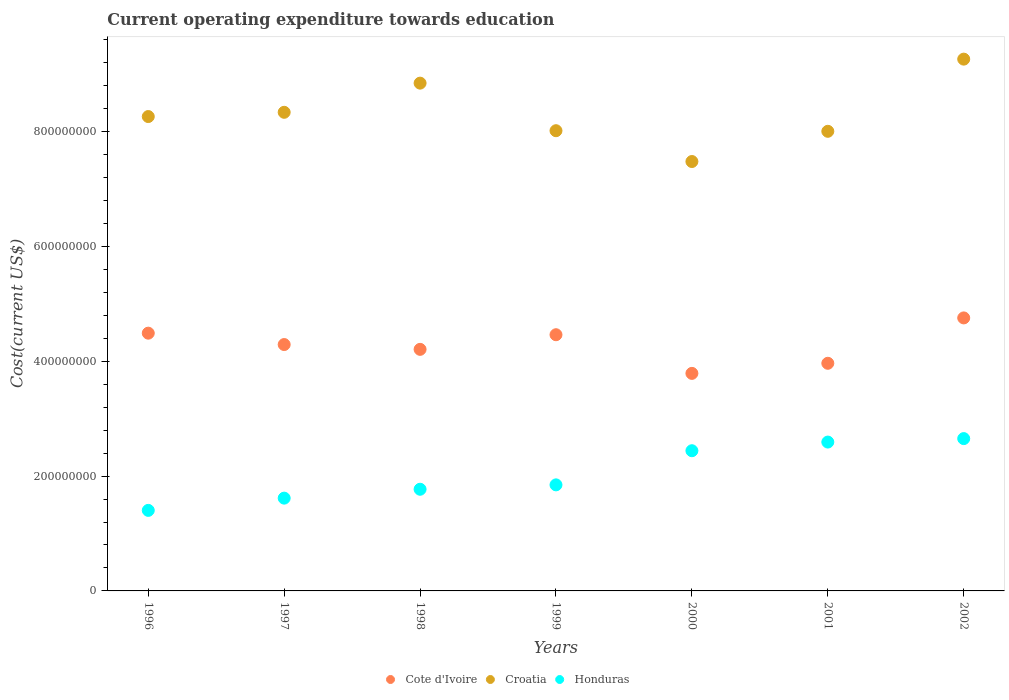Is the number of dotlines equal to the number of legend labels?
Give a very brief answer. Yes. What is the expenditure towards education in Honduras in 1997?
Ensure brevity in your answer.  1.62e+08. Across all years, what is the maximum expenditure towards education in Cote d'Ivoire?
Provide a short and direct response. 4.75e+08. Across all years, what is the minimum expenditure towards education in Cote d'Ivoire?
Ensure brevity in your answer.  3.79e+08. In which year was the expenditure towards education in Cote d'Ivoire minimum?
Provide a succinct answer. 2000. What is the total expenditure towards education in Croatia in the graph?
Your response must be concise. 5.82e+09. What is the difference between the expenditure towards education in Croatia in 1999 and that in 2002?
Offer a very short reply. -1.25e+08. What is the difference between the expenditure towards education in Honduras in 1997 and the expenditure towards education in Cote d'Ivoire in 2000?
Offer a very short reply. -2.17e+08. What is the average expenditure towards education in Croatia per year?
Make the answer very short. 8.31e+08. In the year 1998, what is the difference between the expenditure towards education in Honduras and expenditure towards education in Cote d'Ivoire?
Provide a succinct answer. -2.44e+08. In how many years, is the expenditure towards education in Honduras greater than 760000000 US$?
Ensure brevity in your answer.  0. What is the ratio of the expenditure towards education in Croatia in 1998 to that in 1999?
Keep it short and to the point. 1.1. What is the difference between the highest and the second highest expenditure towards education in Honduras?
Your answer should be very brief. 6.03e+06. What is the difference between the highest and the lowest expenditure towards education in Cote d'Ivoire?
Ensure brevity in your answer.  9.66e+07. In how many years, is the expenditure towards education in Cote d'Ivoire greater than the average expenditure towards education in Cote d'Ivoire taken over all years?
Make the answer very short. 4. Does the expenditure towards education in Cote d'Ivoire monotonically increase over the years?
Give a very brief answer. No. Is the expenditure towards education in Croatia strictly greater than the expenditure towards education in Cote d'Ivoire over the years?
Make the answer very short. Yes. Is the expenditure towards education in Honduras strictly less than the expenditure towards education in Croatia over the years?
Offer a very short reply. Yes. How many years are there in the graph?
Your answer should be very brief. 7. Does the graph contain grids?
Your response must be concise. No. How are the legend labels stacked?
Make the answer very short. Horizontal. What is the title of the graph?
Keep it short and to the point. Current operating expenditure towards education. What is the label or title of the Y-axis?
Provide a short and direct response. Cost(current US$). What is the Cost(current US$) of Cote d'Ivoire in 1996?
Offer a very short reply. 4.49e+08. What is the Cost(current US$) in Croatia in 1996?
Your answer should be compact. 8.26e+08. What is the Cost(current US$) in Honduras in 1996?
Provide a short and direct response. 1.40e+08. What is the Cost(current US$) in Cote d'Ivoire in 1997?
Your response must be concise. 4.29e+08. What is the Cost(current US$) of Croatia in 1997?
Provide a short and direct response. 8.34e+08. What is the Cost(current US$) of Honduras in 1997?
Your response must be concise. 1.62e+08. What is the Cost(current US$) of Cote d'Ivoire in 1998?
Your answer should be compact. 4.21e+08. What is the Cost(current US$) in Croatia in 1998?
Your answer should be very brief. 8.84e+08. What is the Cost(current US$) of Honduras in 1998?
Provide a succinct answer. 1.77e+08. What is the Cost(current US$) of Cote d'Ivoire in 1999?
Your response must be concise. 4.46e+08. What is the Cost(current US$) of Croatia in 1999?
Your answer should be compact. 8.02e+08. What is the Cost(current US$) of Honduras in 1999?
Your answer should be compact. 1.85e+08. What is the Cost(current US$) of Cote d'Ivoire in 2000?
Keep it short and to the point. 3.79e+08. What is the Cost(current US$) in Croatia in 2000?
Provide a short and direct response. 7.48e+08. What is the Cost(current US$) in Honduras in 2000?
Provide a succinct answer. 2.44e+08. What is the Cost(current US$) of Cote d'Ivoire in 2001?
Provide a succinct answer. 3.96e+08. What is the Cost(current US$) of Croatia in 2001?
Offer a terse response. 8.00e+08. What is the Cost(current US$) of Honduras in 2001?
Ensure brevity in your answer.  2.59e+08. What is the Cost(current US$) of Cote d'Ivoire in 2002?
Your response must be concise. 4.75e+08. What is the Cost(current US$) of Croatia in 2002?
Ensure brevity in your answer.  9.26e+08. What is the Cost(current US$) of Honduras in 2002?
Give a very brief answer. 2.65e+08. Across all years, what is the maximum Cost(current US$) in Cote d'Ivoire?
Offer a very short reply. 4.75e+08. Across all years, what is the maximum Cost(current US$) in Croatia?
Provide a succinct answer. 9.26e+08. Across all years, what is the maximum Cost(current US$) in Honduras?
Ensure brevity in your answer.  2.65e+08. Across all years, what is the minimum Cost(current US$) of Cote d'Ivoire?
Your answer should be compact. 3.79e+08. Across all years, what is the minimum Cost(current US$) of Croatia?
Ensure brevity in your answer.  7.48e+08. Across all years, what is the minimum Cost(current US$) in Honduras?
Your answer should be compact. 1.40e+08. What is the total Cost(current US$) in Cote d'Ivoire in the graph?
Offer a terse response. 3.00e+09. What is the total Cost(current US$) in Croatia in the graph?
Your answer should be compact. 5.82e+09. What is the total Cost(current US$) in Honduras in the graph?
Your answer should be very brief. 1.43e+09. What is the difference between the Cost(current US$) in Cote d'Ivoire in 1996 and that in 1997?
Your answer should be compact. 1.98e+07. What is the difference between the Cost(current US$) of Croatia in 1996 and that in 1997?
Your answer should be compact. -7.41e+06. What is the difference between the Cost(current US$) in Honduras in 1996 and that in 1997?
Your response must be concise. -2.13e+07. What is the difference between the Cost(current US$) in Cote d'Ivoire in 1996 and that in 1998?
Provide a short and direct response. 2.82e+07. What is the difference between the Cost(current US$) in Croatia in 1996 and that in 1998?
Ensure brevity in your answer.  -5.82e+07. What is the difference between the Cost(current US$) of Honduras in 1996 and that in 1998?
Offer a very short reply. -3.68e+07. What is the difference between the Cost(current US$) in Cote d'Ivoire in 1996 and that in 1999?
Your answer should be very brief. 2.71e+06. What is the difference between the Cost(current US$) of Croatia in 1996 and that in 1999?
Keep it short and to the point. 2.46e+07. What is the difference between the Cost(current US$) of Honduras in 1996 and that in 1999?
Make the answer very short. -4.44e+07. What is the difference between the Cost(current US$) in Cote d'Ivoire in 1996 and that in 2000?
Your answer should be very brief. 7.00e+07. What is the difference between the Cost(current US$) of Croatia in 1996 and that in 2000?
Provide a succinct answer. 7.83e+07. What is the difference between the Cost(current US$) in Honduras in 1996 and that in 2000?
Provide a succinct answer. -1.04e+08. What is the difference between the Cost(current US$) in Cote d'Ivoire in 1996 and that in 2001?
Make the answer very short. 5.25e+07. What is the difference between the Cost(current US$) of Croatia in 1996 and that in 2001?
Give a very brief answer. 2.57e+07. What is the difference between the Cost(current US$) of Honduras in 1996 and that in 2001?
Offer a terse response. -1.19e+08. What is the difference between the Cost(current US$) in Cote d'Ivoire in 1996 and that in 2002?
Make the answer very short. -2.66e+07. What is the difference between the Cost(current US$) of Croatia in 1996 and that in 2002?
Your answer should be compact. -1.00e+08. What is the difference between the Cost(current US$) of Honduras in 1996 and that in 2002?
Offer a very short reply. -1.25e+08. What is the difference between the Cost(current US$) in Cote d'Ivoire in 1997 and that in 1998?
Keep it short and to the point. 8.38e+06. What is the difference between the Cost(current US$) in Croatia in 1997 and that in 1998?
Your answer should be compact. -5.08e+07. What is the difference between the Cost(current US$) of Honduras in 1997 and that in 1998?
Offer a terse response. -1.55e+07. What is the difference between the Cost(current US$) in Cote d'Ivoire in 1997 and that in 1999?
Give a very brief answer. -1.71e+07. What is the difference between the Cost(current US$) of Croatia in 1997 and that in 1999?
Offer a terse response. 3.21e+07. What is the difference between the Cost(current US$) of Honduras in 1997 and that in 1999?
Make the answer very short. -2.31e+07. What is the difference between the Cost(current US$) in Cote d'Ivoire in 1997 and that in 2000?
Your answer should be very brief. 5.02e+07. What is the difference between the Cost(current US$) of Croatia in 1997 and that in 2000?
Give a very brief answer. 8.57e+07. What is the difference between the Cost(current US$) in Honduras in 1997 and that in 2000?
Give a very brief answer. -8.26e+07. What is the difference between the Cost(current US$) of Cote d'Ivoire in 1997 and that in 2001?
Provide a succinct answer. 3.26e+07. What is the difference between the Cost(current US$) of Croatia in 1997 and that in 2001?
Ensure brevity in your answer.  3.31e+07. What is the difference between the Cost(current US$) of Honduras in 1997 and that in 2001?
Offer a terse response. -9.77e+07. What is the difference between the Cost(current US$) in Cote d'Ivoire in 1997 and that in 2002?
Offer a terse response. -4.64e+07. What is the difference between the Cost(current US$) of Croatia in 1997 and that in 2002?
Ensure brevity in your answer.  -9.26e+07. What is the difference between the Cost(current US$) of Honduras in 1997 and that in 2002?
Keep it short and to the point. -1.04e+08. What is the difference between the Cost(current US$) of Cote d'Ivoire in 1998 and that in 1999?
Your answer should be compact. -2.55e+07. What is the difference between the Cost(current US$) of Croatia in 1998 and that in 1999?
Give a very brief answer. 8.28e+07. What is the difference between the Cost(current US$) in Honduras in 1998 and that in 1999?
Provide a succinct answer. -7.66e+06. What is the difference between the Cost(current US$) in Cote d'Ivoire in 1998 and that in 2000?
Provide a succinct answer. 4.18e+07. What is the difference between the Cost(current US$) of Croatia in 1998 and that in 2000?
Ensure brevity in your answer.  1.37e+08. What is the difference between the Cost(current US$) in Honduras in 1998 and that in 2000?
Keep it short and to the point. -6.71e+07. What is the difference between the Cost(current US$) in Cote d'Ivoire in 1998 and that in 2001?
Offer a terse response. 2.43e+07. What is the difference between the Cost(current US$) in Croatia in 1998 and that in 2001?
Make the answer very short. 8.39e+07. What is the difference between the Cost(current US$) in Honduras in 1998 and that in 2001?
Provide a short and direct response. -8.22e+07. What is the difference between the Cost(current US$) of Cote d'Ivoire in 1998 and that in 2002?
Your response must be concise. -5.48e+07. What is the difference between the Cost(current US$) of Croatia in 1998 and that in 2002?
Your answer should be compact. -4.18e+07. What is the difference between the Cost(current US$) of Honduras in 1998 and that in 2002?
Ensure brevity in your answer.  -8.82e+07. What is the difference between the Cost(current US$) of Cote d'Ivoire in 1999 and that in 2000?
Your answer should be very brief. 6.73e+07. What is the difference between the Cost(current US$) in Croatia in 1999 and that in 2000?
Your answer should be compact. 5.37e+07. What is the difference between the Cost(current US$) of Honduras in 1999 and that in 2000?
Make the answer very short. -5.94e+07. What is the difference between the Cost(current US$) in Cote d'Ivoire in 1999 and that in 2001?
Make the answer very short. 4.97e+07. What is the difference between the Cost(current US$) of Croatia in 1999 and that in 2001?
Provide a succinct answer. 1.05e+06. What is the difference between the Cost(current US$) of Honduras in 1999 and that in 2001?
Your answer should be very brief. -7.45e+07. What is the difference between the Cost(current US$) of Cote d'Ivoire in 1999 and that in 2002?
Make the answer very short. -2.93e+07. What is the difference between the Cost(current US$) in Croatia in 1999 and that in 2002?
Your answer should be very brief. -1.25e+08. What is the difference between the Cost(current US$) in Honduras in 1999 and that in 2002?
Offer a very short reply. -8.06e+07. What is the difference between the Cost(current US$) in Cote d'Ivoire in 2000 and that in 2001?
Provide a short and direct response. -1.76e+07. What is the difference between the Cost(current US$) of Croatia in 2000 and that in 2001?
Keep it short and to the point. -5.26e+07. What is the difference between the Cost(current US$) in Honduras in 2000 and that in 2001?
Provide a succinct answer. -1.51e+07. What is the difference between the Cost(current US$) in Cote d'Ivoire in 2000 and that in 2002?
Provide a succinct answer. -9.66e+07. What is the difference between the Cost(current US$) in Croatia in 2000 and that in 2002?
Provide a succinct answer. -1.78e+08. What is the difference between the Cost(current US$) of Honduras in 2000 and that in 2002?
Provide a short and direct response. -2.11e+07. What is the difference between the Cost(current US$) of Cote d'Ivoire in 2001 and that in 2002?
Provide a short and direct response. -7.90e+07. What is the difference between the Cost(current US$) in Croatia in 2001 and that in 2002?
Provide a short and direct response. -1.26e+08. What is the difference between the Cost(current US$) of Honduras in 2001 and that in 2002?
Your answer should be compact. -6.03e+06. What is the difference between the Cost(current US$) in Cote d'Ivoire in 1996 and the Cost(current US$) in Croatia in 1997?
Your answer should be compact. -3.85e+08. What is the difference between the Cost(current US$) in Cote d'Ivoire in 1996 and the Cost(current US$) in Honduras in 1997?
Your answer should be very brief. 2.87e+08. What is the difference between the Cost(current US$) of Croatia in 1996 and the Cost(current US$) of Honduras in 1997?
Offer a very short reply. 6.65e+08. What is the difference between the Cost(current US$) in Cote d'Ivoire in 1996 and the Cost(current US$) in Croatia in 1998?
Offer a terse response. -4.35e+08. What is the difference between the Cost(current US$) of Cote d'Ivoire in 1996 and the Cost(current US$) of Honduras in 1998?
Ensure brevity in your answer.  2.72e+08. What is the difference between the Cost(current US$) of Croatia in 1996 and the Cost(current US$) of Honduras in 1998?
Ensure brevity in your answer.  6.49e+08. What is the difference between the Cost(current US$) of Cote d'Ivoire in 1996 and the Cost(current US$) of Croatia in 1999?
Give a very brief answer. -3.53e+08. What is the difference between the Cost(current US$) in Cote d'Ivoire in 1996 and the Cost(current US$) in Honduras in 1999?
Provide a succinct answer. 2.64e+08. What is the difference between the Cost(current US$) in Croatia in 1996 and the Cost(current US$) in Honduras in 1999?
Give a very brief answer. 6.41e+08. What is the difference between the Cost(current US$) in Cote d'Ivoire in 1996 and the Cost(current US$) in Croatia in 2000?
Keep it short and to the point. -2.99e+08. What is the difference between the Cost(current US$) in Cote d'Ivoire in 1996 and the Cost(current US$) in Honduras in 2000?
Your response must be concise. 2.05e+08. What is the difference between the Cost(current US$) of Croatia in 1996 and the Cost(current US$) of Honduras in 2000?
Provide a short and direct response. 5.82e+08. What is the difference between the Cost(current US$) in Cote d'Ivoire in 1996 and the Cost(current US$) in Croatia in 2001?
Ensure brevity in your answer.  -3.52e+08. What is the difference between the Cost(current US$) of Cote d'Ivoire in 1996 and the Cost(current US$) of Honduras in 2001?
Keep it short and to the point. 1.90e+08. What is the difference between the Cost(current US$) in Croatia in 1996 and the Cost(current US$) in Honduras in 2001?
Your answer should be very brief. 5.67e+08. What is the difference between the Cost(current US$) of Cote d'Ivoire in 1996 and the Cost(current US$) of Croatia in 2002?
Provide a short and direct response. -4.77e+08. What is the difference between the Cost(current US$) of Cote d'Ivoire in 1996 and the Cost(current US$) of Honduras in 2002?
Provide a short and direct response. 1.84e+08. What is the difference between the Cost(current US$) in Croatia in 1996 and the Cost(current US$) in Honduras in 2002?
Your response must be concise. 5.61e+08. What is the difference between the Cost(current US$) in Cote d'Ivoire in 1997 and the Cost(current US$) in Croatia in 1998?
Provide a succinct answer. -4.55e+08. What is the difference between the Cost(current US$) in Cote d'Ivoire in 1997 and the Cost(current US$) in Honduras in 1998?
Offer a very short reply. 2.52e+08. What is the difference between the Cost(current US$) of Croatia in 1997 and the Cost(current US$) of Honduras in 1998?
Your response must be concise. 6.57e+08. What is the difference between the Cost(current US$) of Cote d'Ivoire in 1997 and the Cost(current US$) of Croatia in 1999?
Make the answer very short. -3.72e+08. What is the difference between the Cost(current US$) in Cote d'Ivoire in 1997 and the Cost(current US$) in Honduras in 1999?
Keep it short and to the point. 2.44e+08. What is the difference between the Cost(current US$) of Croatia in 1997 and the Cost(current US$) of Honduras in 1999?
Offer a very short reply. 6.49e+08. What is the difference between the Cost(current US$) of Cote d'Ivoire in 1997 and the Cost(current US$) of Croatia in 2000?
Your answer should be compact. -3.19e+08. What is the difference between the Cost(current US$) in Cote d'Ivoire in 1997 and the Cost(current US$) in Honduras in 2000?
Offer a very short reply. 1.85e+08. What is the difference between the Cost(current US$) of Croatia in 1997 and the Cost(current US$) of Honduras in 2000?
Your answer should be compact. 5.89e+08. What is the difference between the Cost(current US$) of Cote d'Ivoire in 1997 and the Cost(current US$) of Croatia in 2001?
Make the answer very short. -3.71e+08. What is the difference between the Cost(current US$) of Cote d'Ivoire in 1997 and the Cost(current US$) of Honduras in 2001?
Ensure brevity in your answer.  1.70e+08. What is the difference between the Cost(current US$) in Croatia in 1997 and the Cost(current US$) in Honduras in 2001?
Offer a terse response. 5.74e+08. What is the difference between the Cost(current US$) of Cote d'Ivoire in 1997 and the Cost(current US$) of Croatia in 2002?
Provide a succinct answer. -4.97e+08. What is the difference between the Cost(current US$) of Cote d'Ivoire in 1997 and the Cost(current US$) of Honduras in 2002?
Offer a very short reply. 1.64e+08. What is the difference between the Cost(current US$) in Croatia in 1997 and the Cost(current US$) in Honduras in 2002?
Give a very brief answer. 5.68e+08. What is the difference between the Cost(current US$) in Cote d'Ivoire in 1998 and the Cost(current US$) in Croatia in 1999?
Ensure brevity in your answer.  -3.81e+08. What is the difference between the Cost(current US$) in Cote d'Ivoire in 1998 and the Cost(current US$) in Honduras in 1999?
Your answer should be compact. 2.36e+08. What is the difference between the Cost(current US$) of Croatia in 1998 and the Cost(current US$) of Honduras in 1999?
Keep it short and to the point. 7.00e+08. What is the difference between the Cost(current US$) of Cote d'Ivoire in 1998 and the Cost(current US$) of Croatia in 2000?
Keep it short and to the point. -3.27e+08. What is the difference between the Cost(current US$) of Cote d'Ivoire in 1998 and the Cost(current US$) of Honduras in 2000?
Your answer should be very brief. 1.77e+08. What is the difference between the Cost(current US$) in Croatia in 1998 and the Cost(current US$) in Honduras in 2000?
Provide a short and direct response. 6.40e+08. What is the difference between the Cost(current US$) in Cote d'Ivoire in 1998 and the Cost(current US$) in Croatia in 2001?
Make the answer very short. -3.80e+08. What is the difference between the Cost(current US$) in Cote d'Ivoire in 1998 and the Cost(current US$) in Honduras in 2001?
Make the answer very short. 1.61e+08. What is the difference between the Cost(current US$) in Croatia in 1998 and the Cost(current US$) in Honduras in 2001?
Your response must be concise. 6.25e+08. What is the difference between the Cost(current US$) in Cote d'Ivoire in 1998 and the Cost(current US$) in Croatia in 2002?
Offer a very short reply. -5.05e+08. What is the difference between the Cost(current US$) in Cote d'Ivoire in 1998 and the Cost(current US$) in Honduras in 2002?
Your response must be concise. 1.55e+08. What is the difference between the Cost(current US$) in Croatia in 1998 and the Cost(current US$) in Honduras in 2002?
Ensure brevity in your answer.  6.19e+08. What is the difference between the Cost(current US$) in Cote d'Ivoire in 1999 and the Cost(current US$) in Croatia in 2000?
Offer a very short reply. -3.02e+08. What is the difference between the Cost(current US$) in Cote d'Ivoire in 1999 and the Cost(current US$) in Honduras in 2000?
Your answer should be compact. 2.02e+08. What is the difference between the Cost(current US$) in Croatia in 1999 and the Cost(current US$) in Honduras in 2000?
Provide a short and direct response. 5.57e+08. What is the difference between the Cost(current US$) in Cote d'Ivoire in 1999 and the Cost(current US$) in Croatia in 2001?
Give a very brief answer. -3.54e+08. What is the difference between the Cost(current US$) of Cote d'Ivoire in 1999 and the Cost(current US$) of Honduras in 2001?
Offer a very short reply. 1.87e+08. What is the difference between the Cost(current US$) of Croatia in 1999 and the Cost(current US$) of Honduras in 2001?
Offer a terse response. 5.42e+08. What is the difference between the Cost(current US$) of Cote d'Ivoire in 1999 and the Cost(current US$) of Croatia in 2002?
Your answer should be compact. -4.80e+08. What is the difference between the Cost(current US$) of Cote d'Ivoire in 1999 and the Cost(current US$) of Honduras in 2002?
Your answer should be compact. 1.81e+08. What is the difference between the Cost(current US$) in Croatia in 1999 and the Cost(current US$) in Honduras in 2002?
Provide a succinct answer. 5.36e+08. What is the difference between the Cost(current US$) of Cote d'Ivoire in 2000 and the Cost(current US$) of Croatia in 2001?
Offer a terse response. -4.22e+08. What is the difference between the Cost(current US$) of Cote d'Ivoire in 2000 and the Cost(current US$) of Honduras in 2001?
Offer a very short reply. 1.20e+08. What is the difference between the Cost(current US$) of Croatia in 2000 and the Cost(current US$) of Honduras in 2001?
Provide a short and direct response. 4.89e+08. What is the difference between the Cost(current US$) of Cote d'Ivoire in 2000 and the Cost(current US$) of Croatia in 2002?
Give a very brief answer. -5.47e+08. What is the difference between the Cost(current US$) of Cote d'Ivoire in 2000 and the Cost(current US$) of Honduras in 2002?
Ensure brevity in your answer.  1.14e+08. What is the difference between the Cost(current US$) in Croatia in 2000 and the Cost(current US$) in Honduras in 2002?
Your answer should be compact. 4.83e+08. What is the difference between the Cost(current US$) of Cote d'Ivoire in 2001 and the Cost(current US$) of Croatia in 2002?
Your answer should be very brief. -5.30e+08. What is the difference between the Cost(current US$) in Cote d'Ivoire in 2001 and the Cost(current US$) in Honduras in 2002?
Offer a terse response. 1.31e+08. What is the difference between the Cost(current US$) in Croatia in 2001 and the Cost(current US$) in Honduras in 2002?
Your response must be concise. 5.35e+08. What is the average Cost(current US$) of Cote d'Ivoire per year?
Offer a very short reply. 4.28e+08. What is the average Cost(current US$) of Croatia per year?
Provide a short and direct response. 8.31e+08. What is the average Cost(current US$) in Honduras per year?
Your response must be concise. 2.05e+08. In the year 1996, what is the difference between the Cost(current US$) in Cote d'Ivoire and Cost(current US$) in Croatia?
Provide a short and direct response. -3.77e+08. In the year 1996, what is the difference between the Cost(current US$) in Cote d'Ivoire and Cost(current US$) in Honduras?
Your answer should be compact. 3.09e+08. In the year 1996, what is the difference between the Cost(current US$) of Croatia and Cost(current US$) of Honduras?
Provide a short and direct response. 6.86e+08. In the year 1997, what is the difference between the Cost(current US$) of Cote d'Ivoire and Cost(current US$) of Croatia?
Ensure brevity in your answer.  -4.04e+08. In the year 1997, what is the difference between the Cost(current US$) in Cote d'Ivoire and Cost(current US$) in Honduras?
Ensure brevity in your answer.  2.68e+08. In the year 1997, what is the difference between the Cost(current US$) in Croatia and Cost(current US$) in Honduras?
Provide a short and direct response. 6.72e+08. In the year 1998, what is the difference between the Cost(current US$) in Cote d'Ivoire and Cost(current US$) in Croatia?
Provide a short and direct response. -4.64e+08. In the year 1998, what is the difference between the Cost(current US$) of Cote d'Ivoire and Cost(current US$) of Honduras?
Make the answer very short. 2.44e+08. In the year 1998, what is the difference between the Cost(current US$) of Croatia and Cost(current US$) of Honduras?
Your answer should be compact. 7.07e+08. In the year 1999, what is the difference between the Cost(current US$) of Cote d'Ivoire and Cost(current US$) of Croatia?
Provide a succinct answer. -3.55e+08. In the year 1999, what is the difference between the Cost(current US$) of Cote d'Ivoire and Cost(current US$) of Honduras?
Ensure brevity in your answer.  2.61e+08. In the year 1999, what is the difference between the Cost(current US$) of Croatia and Cost(current US$) of Honduras?
Keep it short and to the point. 6.17e+08. In the year 2000, what is the difference between the Cost(current US$) in Cote d'Ivoire and Cost(current US$) in Croatia?
Provide a short and direct response. -3.69e+08. In the year 2000, what is the difference between the Cost(current US$) of Cote d'Ivoire and Cost(current US$) of Honduras?
Offer a very short reply. 1.35e+08. In the year 2000, what is the difference between the Cost(current US$) of Croatia and Cost(current US$) of Honduras?
Provide a short and direct response. 5.04e+08. In the year 2001, what is the difference between the Cost(current US$) of Cote d'Ivoire and Cost(current US$) of Croatia?
Provide a short and direct response. -4.04e+08. In the year 2001, what is the difference between the Cost(current US$) of Cote d'Ivoire and Cost(current US$) of Honduras?
Ensure brevity in your answer.  1.37e+08. In the year 2001, what is the difference between the Cost(current US$) in Croatia and Cost(current US$) in Honduras?
Provide a short and direct response. 5.41e+08. In the year 2002, what is the difference between the Cost(current US$) of Cote d'Ivoire and Cost(current US$) of Croatia?
Provide a short and direct response. -4.51e+08. In the year 2002, what is the difference between the Cost(current US$) of Cote d'Ivoire and Cost(current US$) of Honduras?
Provide a succinct answer. 2.10e+08. In the year 2002, what is the difference between the Cost(current US$) in Croatia and Cost(current US$) in Honduras?
Provide a short and direct response. 6.61e+08. What is the ratio of the Cost(current US$) in Cote d'Ivoire in 1996 to that in 1997?
Your answer should be very brief. 1.05. What is the ratio of the Cost(current US$) in Croatia in 1996 to that in 1997?
Your answer should be very brief. 0.99. What is the ratio of the Cost(current US$) of Honduras in 1996 to that in 1997?
Provide a succinct answer. 0.87. What is the ratio of the Cost(current US$) in Cote d'Ivoire in 1996 to that in 1998?
Your response must be concise. 1.07. What is the ratio of the Cost(current US$) in Croatia in 1996 to that in 1998?
Offer a very short reply. 0.93. What is the ratio of the Cost(current US$) in Honduras in 1996 to that in 1998?
Your response must be concise. 0.79. What is the ratio of the Cost(current US$) of Croatia in 1996 to that in 1999?
Provide a succinct answer. 1.03. What is the ratio of the Cost(current US$) of Honduras in 1996 to that in 1999?
Offer a terse response. 0.76. What is the ratio of the Cost(current US$) of Cote d'Ivoire in 1996 to that in 2000?
Offer a very short reply. 1.18. What is the ratio of the Cost(current US$) of Croatia in 1996 to that in 2000?
Offer a terse response. 1.1. What is the ratio of the Cost(current US$) of Honduras in 1996 to that in 2000?
Your answer should be very brief. 0.57. What is the ratio of the Cost(current US$) in Cote d'Ivoire in 1996 to that in 2001?
Give a very brief answer. 1.13. What is the ratio of the Cost(current US$) of Croatia in 1996 to that in 2001?
Offer a very short reply. 1.03. What is the ratio of the Cost(current US$) of Honduras in 1996 to that in 2001?
Provide a short and direct response. 0.54. What is the ratio of the Cost(current US$) of Cote d'Ivoire in 1996 to that in 2002?
Keep it short and to the point. 0.94. What is the ratio of the Cost(current US$) of Croatia in 1996 to that in 2002?
Your answer should be compact. 0.89. What is the ratio of the Cost(current US$) of Honduras in 1996 to that in 2002?
Keep it short and to the point. 0.53. What is the ratio of the Cost(current US$) in Cote d'Ivoire in 1997 to that in 1998?
Your response must be concise. 1.02. What is the ratio of the Cost(current US$) in Croatia in 1997 to that in 1998?
Your response must be concise. 0.94. What is the ratio of the Cost(current US$) in Honduras in 1997 to that in 1998?
Offer a terse response. 0.91. What is the ratio of the Cost(current US$) in Cote d'Ivoire in 1997 to that in 1999?
Offer a terse response. 0.96. What is the ratio of the Cost(current US$) of Honduras in 1997 to that in 1999?
Provide a succinct answer. 0.87. What is the ratio of the Cost(current US$) of Cote d'Ivoire in 1997 to that in 2000?
Your answer should be compact. 1.13. What is the ratio of the Cost(current US$) of Croatia in 1997 to that in 2000?
Provide a succinct answer. 1.11. What is the ratio of the Cost(current US$) in Honduras in 1997 to that in 2000?
Offer a terse response. 0.66. What is the ratio of the Cost(current US$) in Cote d'Ivoire in 1997 to that in 2001?
Make the answer very short. 1.08. What is the ratio of the Cost(current US$) in Croatia in 1997 to that in 2001?
Provide a succinct answer. 1.04. What is the ratio of the Cost(current US$) of Honduras in 1997 to that in 2001?
Make the answer very short. 0.62. What is the ratio of the Cost(current US$) of Cote d'Ivoire in 1997 to that in 2002?
Ensure brevity in your answer.  0.9. What is the ratio of the Cost(current US$) in Honduras in 1997 to that in 2002?
Offer a very short reply. 0.61. What is the ratio of the Cost(current US$) in Cote d'Ivoire in 1998 to that in 1999?
Make the answer very short. 0.94. What is the ratio of the Cost(current US$) in Croatia in 1998 to that in 1999?
Provide a short and direct response. 1.1. What is the ratio of the Cost(current US$) of Honduras in 1998 to that in 1999?
Provide a succinct answer. 0.96. What is the ratio of the Cost(current US$) of Cote d'Ivoire in 1998 to that in 2000?
Your answer should be very brief. 1.11. What is the ratio of the Cost(current US$) in Croatia in 1998 to that in 2000?
Give a very brief answer. 1.18. What is the ratio of the Cost(current US$) of Honduras in 1998 to that in 2000?
Your answer should be very brief. 0.73. What is the ratio of the Cost(current US$) of Cote d'Ivoire in 1998 to that in 2001?
Offer a very short reply. 1.06. What is the ratio of the Cost(current US$) in Croatia in 1998 to that in 2001?
Provide a short and direct response. 1.1. What is the ratio of the Cost(current US$) in Honduras in 1998 to that in 2001?
Offer a terse response. 0.68. What is the ratio of the Cost(current US$) of Cote d'Ivoire in 1998 to that in 2002?
Offer a very short reply. 0.88. What is the ratio of the Cost(current US$) in Croatia in 1998 to that in 2002?
Offer a terse response. 0.95. What is the ratio of the Cost(current US$) of Honduras in 1998 to that in 2002?
Give a very brief answer. 0.67. What is the ratio of the Cost(current US$) in Cote d'Ivoire in 1999 to that in 2000?
Keep it short and to the point. 1.18. What is the ratio of the Cost(current US$) of Croatia in 1999 to that in 2000?
Ensure brevity in your answer.  1.07. What is the ratio of the Cost(current US$) of Honduras in 1999 to that in 2000?
Make the answer very short. 0.76. What is the ratio of the Cost(current US$) in Cote d'Ivoire in 1999 to that in 2001?
Provide a short and direct response. 1.13. What is the ratio of the Cost(current US$) of Croatia in 1999 to that in 2001?
Your answer should be compact. 1. What is the ratio of the Cost(current US$) in Honduras in 1999 to that in 2001?
Offer a terse response. 0.71. What is the ratio of the Cost(current US$) of Cote d'Ivoire in 1999 to that in 2002?
Give a very brief answer. 0.94. What is the ratio of the Cost(current US$) in Croatia in 1999 to that in 2002?
Your response must be concise. 0.87. What is the ratio of the Cost(current US$) of Honduras in 1999 to that in 2002?
Keep it short and to the point. 0.7. What is the ratio of the Cost(current US$) of Cote d'Ivoire in 2000 to that in 2001?
Provide a short and direct response. 0.96. What is the ratio of the Cost(current US$) of Croatia in 2000 to that in 2001?
Make the answer very short. 0.93. What is the ratio of the Cost(current US$) of Honduras in 2000 to that in 2001?
Offer a terse response. 0.94. What is the ratio of the Cost(current US$) of Cote d'Ivoire in 2000 to that in 2002?
Give a very brief answer. 0.8. What is the ratio of the Cost(current US$) in Croatia in 2000 to that in 2002?
Make the answer very short. 0.81. What is the ratio of the Cost(current US$) of Honduras in 2000 to that in 2002?
Keep it short and to the point. 0.92. What is the ratio of the Cost(current US$) in Cote d'Ivoire in 2001 to that in 2002?
Keep it short and to the point. 0.83. What is the ratio of the Cost(current US$) in Croatia in 2001 to that in 2002?
Ensure brevity in your answer.  0.86. What is the ratio of the Cost(current US$) of Honduras in 2001 to that in 2002?
Your answer should be compact. 0.98. What is the difference between the highest and the second highest Cost(current US$) of Cote d'Ivoire?
Offer a very short reply. 2.66e+07. What is the difference between the highest and the second highest Cost(current US$) of Croatia?
Make the answer very short. 4.18e+07. What is the difference between the highest and the second highest Cost(current US$) of Honduras?
Your answer should be compact. 6.03e+06. What is the difference between the highest and the lowest Cost(current US$) of Cote d'Ivoire?
Provide a short and direct response. 9.66e+07. What is the difference between the highest and the lowest Cost(current US$) in Croatia?
Provide a succinct answer. 1.78e+08. What is the difference between the highest and the lowest Cost(current US$) in Honduras?
Offer a very short reply. 1.25e+08. 